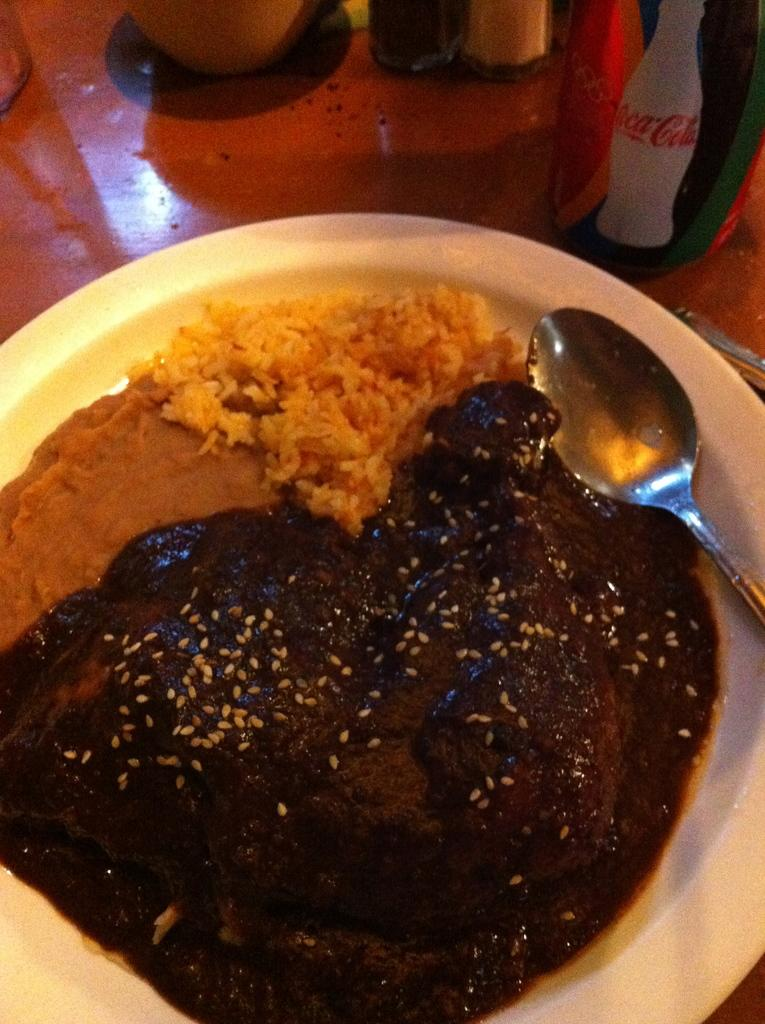What is the color of the table in the image? The table in the image is brown-colored. What is placed on the table? There is a white-colored bowl on the table. What is inside the bowl? The bowl contains a food item. What utensil is present on the table? There is a spoon on the table. Are there any other objects on the table? Yes, there are other objects on the table. What type of rail can be seen in the image? There is no rail present in the image; it features a brown-colored table, a white-colored bowl, a food item, a spoon, and other objects on the table. 